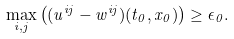<formula> <loc_0><loc_0><loc_500><loc_500>\max _ { i , j } \left ( ( u ^ { i j } - w ^ { i j } ) ( t _ { 0 } , x _ { 0 } ) \right ) \geq \epsilon _ { 0 } .</formula> 